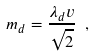<formula> <loc_0><loc_0><loc_500><loc_500>m _ { d } = \frac { \lambda _ { d } v } { \sqrt { 2 } } \ ,</formula> 